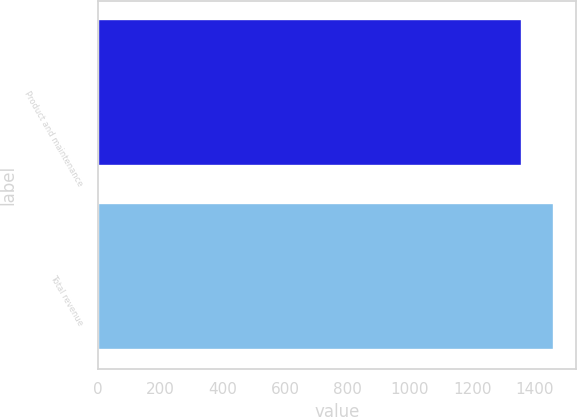Convert chart to OTSL. <chart><loc_0><loc_0><loc_500><loc_500><bar_chart><fcel>Product and maintenance<fcel>Total revenue<nl><fcel>1357.9<fcel>1460.1<nl></chart> 